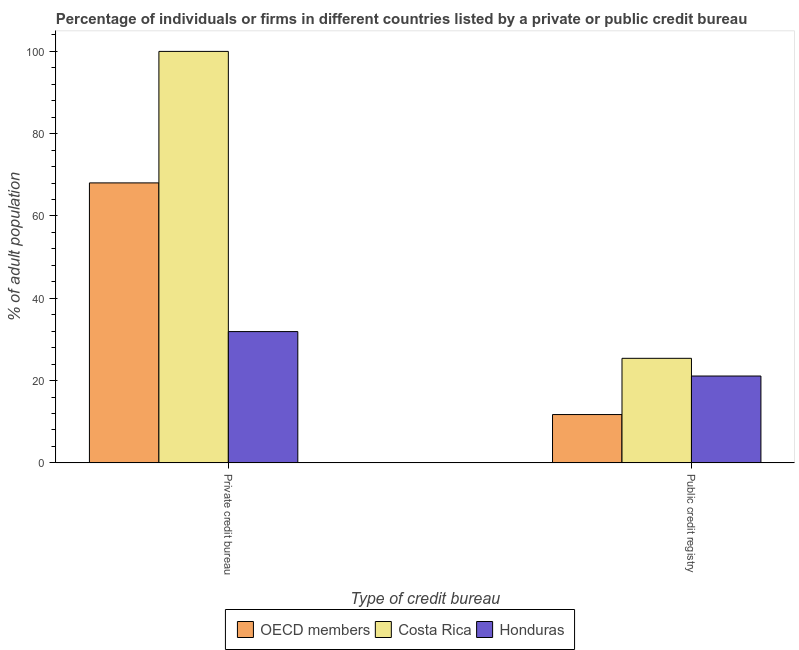How many groups of bars are there?
Ensure brevity in your answer.  2. Are the number of bars on each tick of the X-axis equal?
Make the answer very short. Yes. How many bars are there on the 2nd tick from the left?
Provide a short and direct response. 3. How many bars are there on the 2nd tick from the right?
Your response must be concise. 3. What is the label of the 2nd group of bars from the left?
Give a very brief answer. Public credit registry. What is the percentage of firms listed by private credit bureau in OECD members?
Offer a terse response. 68.04. Across all countries, what is the maximum percentage of firms listed by private credit bureau?
Your answer should be very brief. 100. Across all countries, what is the minimum percentage of firms listed by private credit bureau?
Offer a very short reply. 31.9. In which country was the percentage of firms listed by public credit bureau minimum?
Offer a very short reply. OECD members. What is the total percentage of firms listed by public credit bureau in the graph?
Provide a succinct answer. 58.23. What is the difference between the percentage of firms listed by private credit bureau in OECD members and that in Honduras?
Make the answer very short. 36.14. What is the difference between the percentage of firms listed by private credit bureau in Honduras and the percentage of firms listed by public credit bureau in Costa Rica?
Your answer should be very brief. 6.5. What is the average percentage of firms listed by public credit bureau per country?
Provide a succinct answer. 19.41. What is the difference between the percentage of firms listed by public credit bureau and percentage of firms listed by private credit bureau in Costa Rica?
Keep it short and to the point. -74.6. What is the ratio of the percentage of firms listed by public credit bureau in Costa Rica to that in Honduras?
Give a very brief answer. 1.2. In how many countries, is the percentage of firms listed by public credit bureau greater than the average percentage of firms listed by public credit bureau taken over all countries?
Keep it short and to the point. 2. What does the 1st bar from the left in Public credit registry represents?
Your answer should be very brief. OECD members. What does the 2nd bar from the right in Public credit registry represents?
Your answer should be compact. Costa Rica. Are all the bars in the graph horizontal?
Give a very brief answer. No. How many countries are there in the graph?
Make the answer very short. 3. What is the difference between two consecutive major ticks on the Y-axis?
Offer a very short reply. 20. Does the graph contain any zero values?
Keep it short and to the point. No. Where does the legend appear in the graph?
Offer a terse response. Bottom center. What is the title of the graph?
Make the answer very short. Percentage of individuals or firms in different countries listed by a private or public credit bureau. What is the label or title of the X-axis?
Your answer should be very brief. Type of credit bureau. What is the label or title of the Y-axis?
Offer a terse response. % of adult population. What is the % of adult population in OECD members in Private credit bureau?
Make the answer very short. 68.04. What is the % of adult population of Costa Rica in Private credit bureau?
Provide a short and direct response. 100. What is the % of adult population of Honduras in Private credit bureau?
Give a very brief answer. 31.9. What is the % of adult population in OECD members in Public credit registry?
Keep it short and to the point. 11.73. What is the % of adult population in Costa Rica in Public credit registry?
Give a very brief answer. 25.4. What is the % of adult population in Honduras in Public credit registry?
Your answer should be very brief. 21.1. Across all Type of credit bureau, what is the maximum % of adult population of OECD members?
Provide a short and direct response. 68.04. Across all Type of credit bureau, what is the maximum % of adult population of Costa Rica?
Provide a short and direct response. 100. Across all Type of credit bureau, what is the maximum % of adult population of Honduras?
Offer a very short reply. 31.9. Across all Type of credit bureau, what is the minimum % of adult population of OECD members?
Provide a short and direct response. 11.73. Across all Type of credit bureau, what is the minimum % of adult population of Costa Rica?
Your response must be concise. 25.4. Across all Type of credit bureau, what is the minimum % of adult population of Honduras?
Offer a very short reply. 21.1. What is the total % of adult population of OECD members in the graph?
Offer a terse response. 79.77. What is the total % of adult population of Costa Rica in the graph?
Your answer should be compact. 125.4. What is the difference between the % of adult population in OECD members in Private credit bureau and that in Public credit registry?
Provide a short and direct response. 56.31. What is the difference between the % of adult population of Costa Rica in Private credit bureau and that in Public credit registry?
Your response must be concise. 74.6. What is the difference between the % of adult population in Honduras in Private credit bureau and that in Public credit registry?
Your response must be concise. 10.8. What is the difference between the % of adult population of OECD members in Private credit bureau and the % of adult population of Costa Rica in Public credit registry?
Make the answer very short. 42.64. What is the difference between the % of adult population in OECD members in Private credit bureau and the % of adult population in Honduras in Public credit registry?
Make the answer very short. 46.94. What is the difference between the % of adult population of Costa Rica in Private credit bureau and the % of adult population of Honduras in Public credit registry?
Provide a short and direct response. 78.9. What is the average % of adult population in OECD members per Type of credit bureau?
Offer a very short reply. 39.89. What is the average % of adult population in Costa Rica per Type of credit bureau?
Offer a very short reply. 62.7. What is the average % of adult population in Honduras per Type of credit bureau?
Give a very brief answer. 26.5. What is the difference between the % of adult population in OECD members and % of adult population in Costa Rica in Private credit bureau?
Provide a succinct answer. -31.96. What is the difference between the % of adult population of OECD members and % of adult population of Honduras in Private credit bureau?
Your answer should be compact. 36.14. What is the difference between the % of adult population of Costa Rica and % of adult population of Honduras in Private credit bureau?
Your answer should be compact. 68.1. What is the difference between the % of adult population in OECD members and % of adult population in Costa Rica in Public credit registry?
Your answer should be very brief. -13.67. What is the difference between the % of adult population of OECD members and % of adult population of Honduras in Public credit registry?
Give a very brief answer. -9.37. What is the difference between the % of adult population of Costa Rica and % of adult population of Honduras in Public credit registry?
Your answer should be compact. 4.3. What is the ratio of the % of adult population in OECD members in Private credit bureau to that in Public credit registry?
Give a very brief answer. 5.8. What is the ratio of the % of adult population in Costa Rica in Private credit bureau to that in Public credit registry?
Your answer should be compact. 3.94. What is the ratio of the % of adult population of Honduras in Private credit bureau to that in Public credit registry?
Your answer should be compact. 1.51. What is the difference between the highest and the second highest % of adult population in OECD members?
Your answer should be very brief. 56.31. What is the difference between the highest and the second highest % of adult population in Costa Rica?
Keep it short and to the point. 74.6. What is the difference between the highest and the lowest % of adult population of OECD members?
Keep it short and to the point. 56.31. What is the difference between the highest and the lowest % of adult population in Costa Rica?
Offer a very short reply. 74.6. What is the difference between the highest and the lowest % of adult population in Honduras?
Keep it short and to the point. 10.8. 